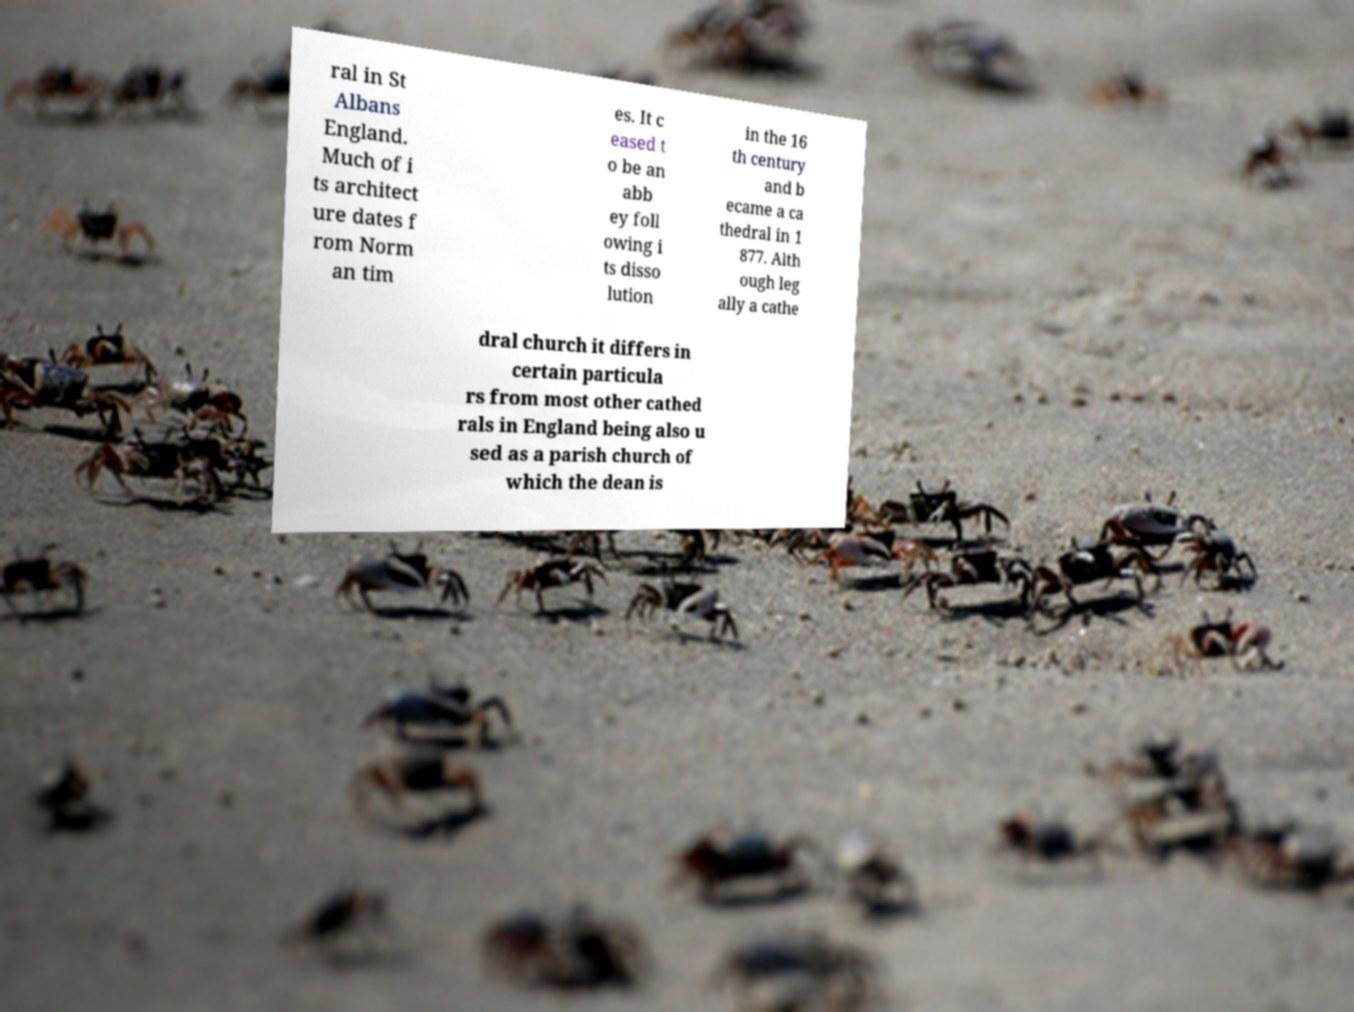Please identify and transcribe the text found in this image. ral in St Albans England. Much of i ts architect ure dates f rom Norm an tim es. It c eased t o be an abb ey foll owing i ts disso lution in the 16 th century and b ecame a ca thedral in 1 877. Alth ough leg ally a cathe dral church it differs in certain particula rs from most other cathed rals in England being also u sed as a parish church of which the dean is 